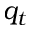<formula> <loc_0><loc_0><loc_500><loc_500>q _ { t }</formula> 